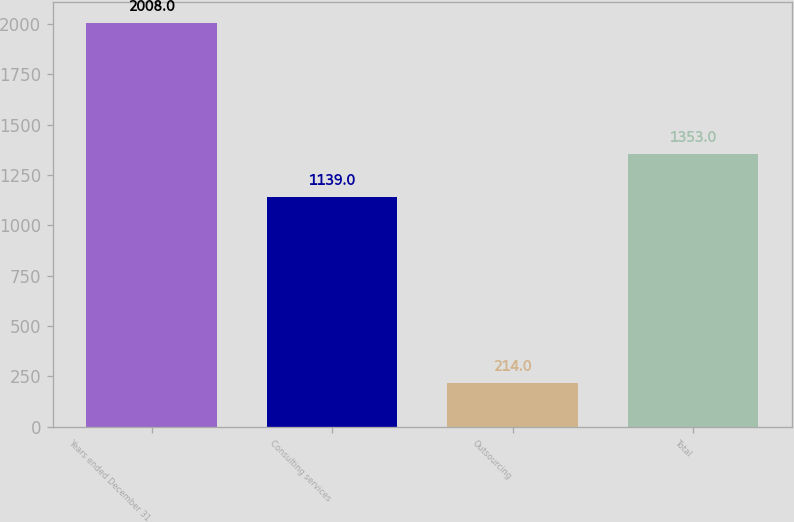<chart> <loc_0><loc_0><loc_500><loc_500><bar_chart><fcel>Years ended December 31<fcel>Consulting services<fcel>Outsourcing<fcel>Total<nl><fcel>2008<fcel>1139<fcel>214<fcel>1353<nl></chart> 